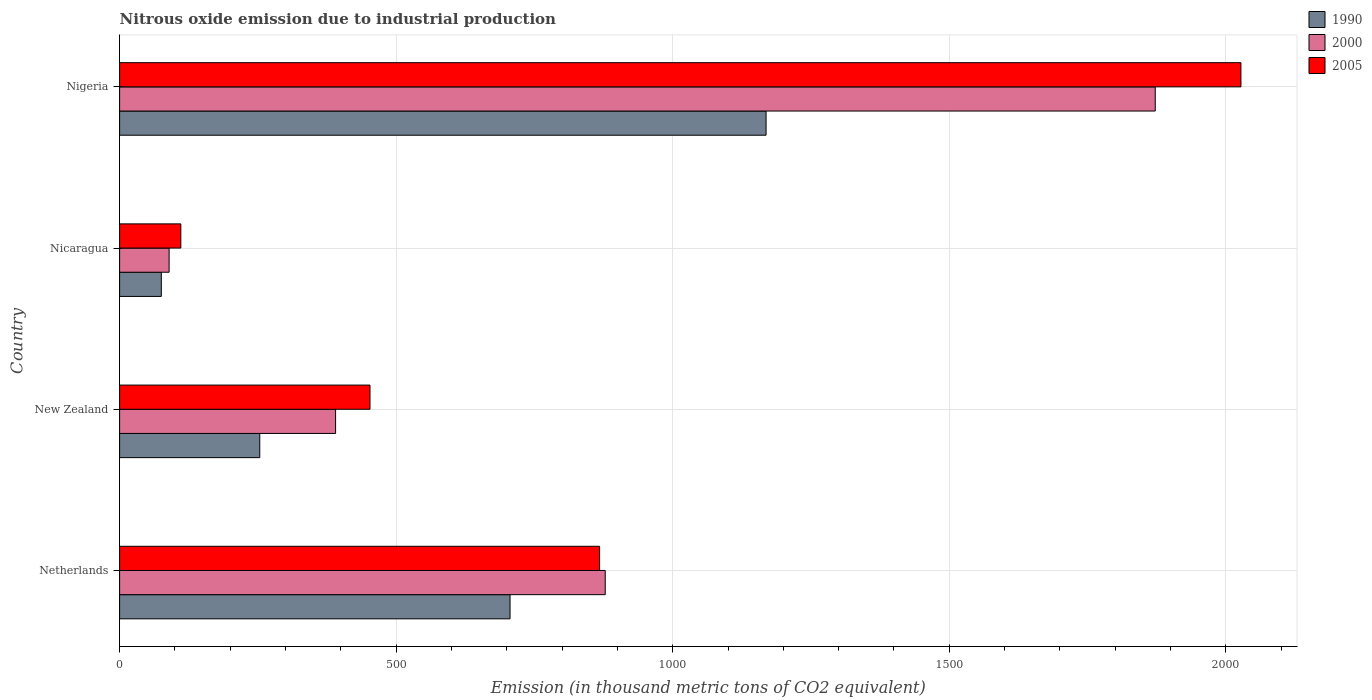How many groups of bars are there?
Ensure brevity in your answer.  4. Are the number of bars per tick equal to the number of legend labels?
Give a very brief answer. Yes. Are the number of bars on each tick of the Y-axis equal?
Your answer should be compact. Yes. How many bars are there on the 1st tick from the top?
Your answer should be compact. 3. How many bars are there on the 2nd tick from the bottom?
Offer a terse response. 3. What is the label of the 1st group of bars from the top?
Ensure brevity in your answer.  Nigeria. What is the amount of nitrous oxide emitted in 1990 in Nigeria?
Provide a short and direct response. 1168.8. Across all countries, what is the maximum amount of nitrous oxide emitted in 1990?
Your response must be concise. 1168.8. Across all countries, what is the minimum amount of nitrous oxide emitted in 2005?
Keep it short and to the point. 110.7. In which country was the amount of nitrous oxide emitted in 2000 maximum?
Provide a succinct answer. Nigeria. In which country was the amount of nitrous oxide emitted in 1990 minimum?
Offer a terse response. Nicaragua. What is the total amount of nitrous oxide emitted in 2005 in the graph?
Your answer should be very brief. 3458.5. What is the difference between the amount of nitrous oxide emitted in 2005 in New Zealand and that in Nicaragua?
Your answer should be compact. 342. What is the difference between the amount of nitrous oxide emitted in 2000 in New Zealand and the amount of nitrous oxide emitted in 2005 in Nicaragua?
Offer a very short reply. 279.8. What is the average amount of nitrous oxide emitted in 2005 per country?
Make the answer very short. 864.62. What is the difference between the amount of nitrous oxide emitted in 2000 and amount of nitrous oxide emitted in 2005 in Nicaragua?
Provide a short and direct response. -21.2. In how many countries, is the amount of nitrous oxide emitted in 1990 greater than 1700 thousand metric tons?
Give a very brief answer. 0. What is the ratio of the amount of nitrous oxide emitted in 2000 in Netherlands to that in Nigeria?
Keep it short and to the point. 0.47. Is the amount of nitrous oxide emitted in 1990 in Nicaragua less than that in Nigeria?
Offer a very short reply. Yes. What is the difference between the highest and the second highest amount of nitrous oxide emitted in 2005?
Your answer should be compact. 1159.5. What is the difference between the highest and the lowest amount of nitrous oxide emitted in 2000?
Your answer should be compact. 1782.9. In how many countries, is the amount of nitrous oxide emitted in 2000 greater than the average amount of nitrous oxide emitted in 2000 taken over all countries?
Your answer should be compact. 2. Is the sum of the amount of nitrous oxide emitted in 1990 in Nicaragua and Nigeria greater than the maximum amount of nitrous oxide emitted in 2005 across all countries?
Provide a short and direct response. No. What does the 1st bar from the bottom in Netherlands represents?
Ensure brevity in your answer.  1990. Is it the case that in every country, the sum of the amount of nitrous oxide emitted in 1990 and amount of nitrous oxide emitted in 2005 is greater than the amount of nitrous oxide emitted in 2000?
Provide a short and direct response. Yes. What is the difference between two consecutive major ticks on the X-axis?
Provide a short and direct response. 500. Are the values on the major ticks of X-axis written in scientific E-notation?
Provide a succinct answer. No. Does the graph contain grids?
Your answer should be compact. Yes. Where does the legend appear in the graph?
Your answer should be very brief. Top right. How are the legend labels stacked?
Your response must be concise. Vertical. What is the title of the graph?
Provide a succinct answer. Nitrous oxide emission due to industrial production. What is the label or title of the X-axis?
Offer a terse response. Emission (in thousand metric tons of CO2 equivalent). What is the label or title of the Y-axis?
Offer a very short reply. Country. What is the Emission (in thousand metric tons of CO2 equivalent) in 1990 in Netherlands?
Your response must be concise. 705.9. What is the Emission (in thousand metric tons of CO2 equivalent) in 2000 in Netherlands?
Give a very brief answer. 878. What is the Emission (in thousand metric tons of CO2 equivalent) of 2005 in Netherlands?
Your answer should be compact. 867.8. What is the Emission (in thousand metric tons of CO2 equivalent) in 1990 in New Zealand?
Provide a succinct answer. 253.4. What is the Emission (in thousand metric tons of CO2 equivalent) of 2000 in New Zealand?
Make the answer very short. 390.5. What is the Emission (in thousand metric tons of CO2 equivalent) in 2005 in New Zealand?
Your answer should be compact. 452.7. What is the Emission (in thousand metric tons of CO2 equivalent) in 1990 in Nicaragua?
Make the answer very short. 75.4. What is the Emission (in thousand metric tons of CO2 equivalent) of 2000 in Nicaragua?
Offer a very short reply. 89.5. What is the Emission (in thousand metric tons of CO2 equivalent) of 2005 in Nicaragua?
Offer a terse response. 110.7. What is the Emission (in thousand metric tons of CO2 equivalent) of 1990 in Nigeria?
Offer a very short reply. 1168.8. What is the Emission (in thousand metric tons of CO2 equivalent) in 2000 in Nigeria?
Provide a short and direct response. 1872.4. What is the Emission (in thousand metric tons of CO2 equivalent) of 2005 in Nigeria?
Ensure brevity in your answer.  2027.3. Across all countries, what is the maximum Emission (in thousand metric tons of CO2 equivalent) of 1990?
Give a very brief answer. 1168.8. Across all countries, what is the maximum Emission (in thousand metric tons of CO2 equivalent) of 2000?
Your response must be concise. 1872.4. Across all countries, what is the maximum Emission (in thousand metric tons of CO2 equivalent) in 2005?
Provide a short and direct response. 2027.3. Across all countries, what is the minimum Emission (in thousand metric tons of CO2 equivalent) in 1990?
Your answer should be very brief. 75.4. Across all countries, what is the minimum Emission (in thousand metric tons of CO2 equivalent) in 2000?
Provide a short and direct response. 89.5. Across all countries, what is the minimum Emission (in thousand metric tons of CO2 equivalent) of 2005?
Provide a short and direct response. 110.7. What is the total Emission (in thousand metric tons of CO2 equivalent) of 1990 in the graph?
Your answer should be compact. 2203.5. What is the total Emission (in thousand metric tons of CO2 equivalent) of 2000 in the graph?
Your answer should be very brief. 3230.4. What is the total Emission (in thousand metric tons of CO2 equivalent) of 2005 in the graph?
Your answer should be compact. 3458.5. What is the difference between the Emission (in thousand metric tons of CO2 equivalent) of 1990 in Netherlands and that in New Zealand?
Keep it short and to the point. 452.5. What is the difference between the Emission (in thousand metric tons of CO2 equivalent) of 2000 in Netherlands and that in New Zealand?
Keep it short and to the point. 487.5. What is the difference between the Emission (in thousand metric tons of CO2 equivalent) in 2005 in Netherlands and that in New Zealand?
Provide a succinct answer. 415.1. What is the difference between the Emission (in thousand metric tons of CO2 equivalent) in 1990 in Netherlands and that in Nicaragua?
Offer a very short reply. 630.5. What is the difference between the Emission (in thousand metric tons of CO2 equivalent) of 2000 in Netherlands and that in Nicaragua?
Provide a short and direct response. 788.5. What is the difference between the Emission (in thousand metric tons of CO2 equivalent) in 2005 in Netherlands and that in Nicaragua?
Provide a short and direct response. 757.1. What is the difference between the Emission (in thousand metric tons of CO2 equivalent) of 1990 in Netherlands and that in Nigeria?
Your answer should be very brief. -462.9. What is the difference between the Emission (in thousand metric tons of CO2 equivalent) in 2000 in Netherlands and that in Nigeria?
Offer a terse response. -994.4. What is the difference between the Emission (in thousand metric tons of CO2 equivalent) of 2005 in Netherlands and that in Nigeria?
Give a very brief answer. -1159.5. What is the difference between the Emission (in thousand metric tons of CO2 equivalent) of 1990 in New Zealand and that in Nicaragua?
Offer a terse response. 178. What is the difference between the Emission (in thousand metric tons of CO2 equivalent) of 2000 in New Zealand and that in Nicaragua?
Ensure brevity in your answer.  301. What is the difference between the Emission (in thousand metric tons of CO2 equivalent) in 2005 in New Zealand and that in Nicaragua?
Your response must be concise. 342. What is the difference between the Emission (in thousand metric tons of CO2 equivalent) in 1990 in New Zealand and that in Nigeria?
Offer a very short reply. -915.4. What is the difference between the Emission (in thousand metric tons of CO2 equivalent) of 2000 in New Zealand and that in Nigeria?
Give a very brief answer. -1481.9. What is the difference between the Emission (in thousand metric tons of CO2 equivalent) of 2005 in New Zealand and that in Nigeria?
Your answer should be compact. -1574.6. What is the difference between the Emission (in thousand metric tons of CO2 equivalent) in 1990 in Nicaragua and that in Nigeria?
Provide a succinct answer. -1093.4. What is the difference between the Emission (in thousand metric tons of CO2 equivalent) in 2000 in Nicaragua and that in Nigeria?
Your response must be concise. -1782.9. What is the difference between the Emission (in thousand metric tons of CO2 equivalent) of 2005 in Nicaragua and that in Nigeria?
Your response must be concise. -1916.6. What is the difference between the Emission (in thousand metric tons of CO2 equivalent) of 1990 in Netherlands and the Emission (in thousand metric tons of CO2 equivalent) of 2000 in New Zealand?
Make the answer very short. 315.4. What is the difference between the Emission (in thousand metric tons of CO2 equivalent) in 1990 in Netherlands and the Emission (in thousand metric tons of CO2 equivalent) in 2005 in New Zealand?
Your answer should be compact. 253.2. What is the difference between the Emission (in thousand metric tons of CO2 equivalent) in 2000 in Netherlands and the Emission (in thousand metric tons of CO2 equivalent) in 2005 in New Zealand?
Keep it short and to the point. 425.3. What is the difference between the Emission (in thousand metric tons of CO2 equivalent) in 1990 in Netherlands and the Emission (in thousand metric tons of CO2 equivalent) in 2000 in Nicaragua?
Your answer should be compact. 616.4. What is the difference between the Emission (in thousand metric tons of CO2 equivalent) of 1990 in Netherlands and the Emission (in thousand metric tons of CO2 equivalent) of 2005 in Nicaragua?
Provide a succinct answer. 595.2. What is the difference between the Emission (in thousand metric tons of CO2 equivalent) in 2000 in Netherlands and the Emission (in thousand metric tons of CO2 equivalent) in 2005 in Nicaragua?
Give a very brief answer. 767.3. What is the difference between the Emission (in thousand metric tons of CO2 equivalent) of 1990 in Netherlands and the Emission (in thousand metric tons of CO2 equivalent) of 2000 in Nigeria?
Give a very brief answer. -1166.5. What is the difference between the Emission (in thousand metric tons of CO2 equivalent) in 1990 in Netherlands and the Emission (in thousand metric tons of CO2 equivalent) in 2005 in Nigeria?
Make the answer very short. -1321.4. What is the difference between the Emission (in thousand metric tons of CO2 equivalent) of 2000 in Netherlands and the Emission (in thousand metric tons of CO2 equivalent) of 2005 in Nigeria?
Offer a terse response. -1149.3. What is the difference between the Emission (in thousand metric tons of CO2 equivalent) of 1990 in New Zealand and the Emission (in thousand metric tons of CO2 equivalent) of 2000 in Nicaragua?
Offer a very short reply. 163.9. What is the difference between the Emission (in thousand metric tons of CO2 equivalent) of 1990 in New Zealand and the Emission (in thousand metric tons of CO2 equivalent) of 2005 in Nicaragua?
Provide a short and direct response. 142.7. What is the difference between the Emission (in thousand metric tons of CO2 equivalent) of 2000 in New Zealand and the Emission (in thousand metric tons of CO2 equivalent) of 2005 in Nicaragua?
Your response must be concise. 279.8. What is the difference between the Emission (in thousand metric tons of CO2 equivalent) in 1990 in New Zealand and the Emission (in thousand metric tons of CO2 equivalent) in 2000 in Nigeria?
Give a very brief answer. -1619. What is the difference between the Emission (in thousand metric tons of CO2 equivalent) in 1990 in New Zealand and the Emission (in thousand metric tons of CO2 equivalent) in 2005 in Nigeria?
Your answer should be very brief. -1773.9. What is the difference between the Emission (in thousand metric tons of CO2 equivalent) in 2000 in New Zealand and the Emission (in thousand metric tons of CO2 equivalent) in 2005 in Nigeria?
Ensure brevity in your answer.  -1636.8. What is the difference between the Emission (in thousand metric tons of CO2 equivalent) in 1990 in Nicaragua and the Emission (in thousand metric tons of CO2 equivalent) in 2000 in Nigeria?
Your answer should be compact. -1797. What is the difference between the Emission (in thousand metric tons of CO2 equivalent) in 1990 in Nicaragua and the Emission (in thousand metric tons of CO2 equivalent) in 2005 in Nigeria?
Your answer should be very brief. -1951.9. What is the difference between the Emission (in thousand metric tons of CO2 equivalent) in 2000 in Nicaragua and the Emission (in thousand metric tons of CO2 equivalent) in 2005 in Nigeria?
Keep it short and to the point. -1937.8. What is the average Emission (in thousand metric tons of CO2 equivalent) in 1990 per country?
Your answer should be compact. 550.88. What is the average Emission (in thousand metric tons of CO2 equivalent) in 2000 per country?
Give a very brief answer. 807.6. What is the average Emission (in thousand metric tons of CO2 equivalent) of 2005 per country?
Provide a succinct answer. 864.62. What is the difference between the Emission (in thousand metric tons of CO2 equivalent) of 1990 and Emission (in thousand metric tons of CO2 equivalent) of 2000 in Netherlands?
Your answer should be very brief. -172.1. What is the difference between the Emission (in thousand metric tons of CO2 equivalent) of 1990 and Emission (in thousand metric tons of CO2 equivalent) of 2005 in Netherlands?
Provide a succinct answer. -161.9. What is the difference between the Emission (in thousand metric tons of CO2 equivalent) of 1990 and Emission (in thousand metric tons of CO2 equivalent) of 2000 in New Zealand?
Make the answer very short. -137.1. What is the difference between the Emission (in thousand metric tons of CO2 equivalent) in 1990 and Emission (in thousand metric tons of CO2 equivalent) in 2005 in New Zealand?
Offer a terse response. -199.3. What is the difference between the Emission (in thousand metric tons of CO2 equivalent) of 2000 and Emission (in thousand metric tons of CO2 equivalent) of 2005 in New Zealand?
Your answer should be very brief. -62.2. What is the difference between the Emission (in thousand metric tons of CO2 equivalent) in 1990 and Emission (in thousand metric tons of CO2 equivalent) in 2000 in Nicaragua?
Provide a short and direct response. -14.1. What is the difference between the Emission (in thousand metric tons of CO2 equivalent) in 1990 and Emission (in thousand metric tons of CO2 equivalent) in 2005 in Nicaragua?
Your response must be concise. -35.3. What is the difference between the Emission (in thousand metric tons of CO2 equivalent) in 2000 and Emission (in thousand metric tons of CO2 equivalent) in 2005 in Nicaragua?
Offer a terse response. -21.2. What is the difference between the Emission (in thousand metric tons of CO2 equivalent) in 1990 and Emission (in thousand metric tons of CO2 equivalent) in 2000 in Nigeria?
Your answer should be very brief. -703.6. What is the difference between the Emission (in thousand metric tons of CO2 equivalent) of 1990 and Emission (in thousand metric tons of CO2 equivalent) of 2005 in Nigeria?
Offer a very short reply. -858.5. What is the difference between the Emission (in thousand metric tons of CO2 equivalent) of 2000 and Emission (in thousand metric tons of CO2 equivalent) of 2005 in Nigeria?
Your answer should be compact. -154.9. What is the ratio of the Emission (in thousand metric tons of CO2 equivalent) of 1990 in Netherlands to that in New Zealand?
Ensure brevity in your answer.  2.79. What is the ratio of the Emission (in thousand metric tons of CO2 equivalent) of 2000 in Netherlands to that in New Zealand?
Make the answer very short. 2.25. What is the ratio of the Emission (in thousand metric tons of CO2 equivalent) of 2005 in Netherlands to that in New Zealand?
Your answer should be very brief. 1.92. What is the ratio of the Emission (in thousand metric tons of CO2 equivalent) of 1990 in Netherlands to that in Nicaragua?
Offer a terse response. 9.36. What is the ratio of the Emission (in thousand metric tons of CO2 equivalent) of 2000 in Netherlands to that in Nicaragua?
Keep it short and to the point. 9.81. What is the ratio of the Emission (in thousand metric tons of CO2 equivalent) of 2005 in Netherlands to that in Nicaragua?
Give a very brief answer. 7.84. What is the ratio of the Emission (in thousand metric tons of CO2 equivalent) of 1990 in Netherlands to that in Nigeria?
Make the answer very short. 0.6. What is the ratio of the Emission (in thousand metric tons of CO2 equivalent) in 2000 in Netherlands to that in Nigeria?
Provide a succinct answer. 0.47. What is the ratio of the Emission (in thousand metric tons of CO2 equivalent) in 2005 in Netherlands to that in Nigeria?
Your response must be concise. 0.43. What is the ratio of the Emission (in thousand metric tons of CO2 equivalent) in 1990 in New Zealand to that in Nicaragua?
Offer a very short reply. 3.36. What is the ratio of the Emission (in thousand metric tons of CO2 equivalent) of 2000 in New Zealand to that in Nicaragua?
Make the answer very short. 4.36. What is the ratio of the Emission (in thousand metric tons of CO2 equivalent) in 2005 in New Zealand to that in Nicaragua?
Your response must be concise. 4.09. What is the ratio of the Emission (in thousand metric tons of CO2 equivalent) in 1990 in New Zealand to that in Nigeria?
Provide a short and direct response. 0.22. What is the ratio of the Emission (in thousand metric tons of CO2 equivalent) of 2000 in New Zealand to that in Nigeria?
Offer a terse response. 0.21. What is the ratio of the Emission (in thousand metric tons of CO2 equivalent) of 2005 in New Zealand to that in Nigeria?
Your answer should be very brief. 0.22. What is the ratio of the Emission (in thousand metric tons of CO2 equivalent) in 1990 in Nicaragua to that in Nigeria?
Keep it short and to the point. 0.06. What is the ratio of the Emission (in thousand metric tons of CO2 equivalent) of 2000 in Nicaragua to that in Nigeria?
Ensure brevity in your answer.  0.05. What is the ratio of the Emission (in thousand metric tons of CO2 equivalent) in 2005 in Nicaragua to that in Nigeria?
Offer a very short reply. 0.05. What is the difference between the highest and the second highest Emission (in thousand metric tons of CO2 equivalent) of 1990?
Provide a succinct answer. 462.9. What is the difference between the highest and the second highest Emission (in thousand metric tons of CO2 equivalent) in 2000?
Keep it short and to the point. 994.4. What is the difference between the highest and the second highest Emission (in thousand metric tons of CO2 equivalent) in 2005?
Make the answer very short. 1159.5. What is the difference between the highest and the lowest Emission (in thousand metric tons of CO2 equivalent) of 1990?
Your answer should be very brief. 1093.4. What is the difference between the highest and the lowest Emission (in thousand metric tons of CO2 equivalent) of 2000?
Your response must be concise. 1782.9. What is the difference between the highest and the lowest Emission (in thousand metric tons of CO2 equivalent) of 2005?
Keep it short and to the point. 1916.6. 